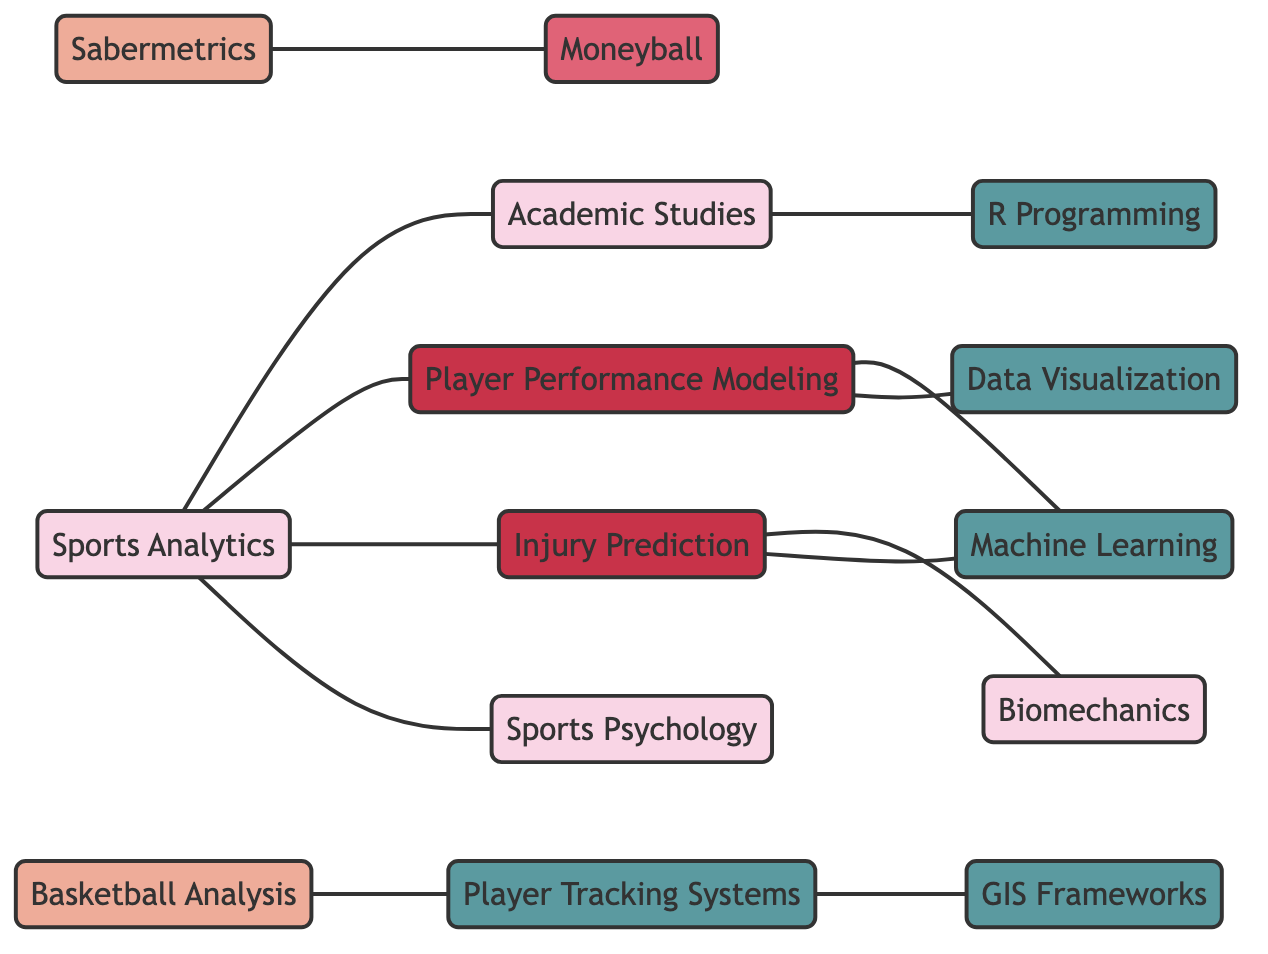What are the two main fields represented in the diagram? The two main fields represented as nodes are "Sports Analytics" and "Academic Studies." These nodes are central to understanding the interconnections illustrated in the network.
Answer: Sports Analytics, Academic Studies How many total nodes are present in the diagram? By counting each unique point of interest in the diagram, we find there are 13 distinct nodes representing different aspects of sports analytics and related fields.
Answer: 13 What methodology is connected to the case study "Moneyball"? The methodology directly linked to the "Moneyball" case study is "Sabermetrics." This connection suggests that "Moneyball" employs "Sabermetrics" as its analytical approach.
Answer: Sabermetrics Which technology is linked to "Player Performance Modeling"? "Machine Learning" is linked to "Player Performance Modeling" as a technology utilized to enhance understanding of player metrics and predictions.
Answer: Machine Learning How many research topics are present in the diagram? There are two distinct research topics present in the diagram: "Player Performance Modeling" and "Injury Prediction." Both focus on specific analytical challenges in sports.
Answer: 2 What field is associated with "Injury Prediction"? "Biomechanics" is associated with "Injury Prediction," suggesting a focus on the physical movements and mechanics that contribute to sports injuries.
Answer: Biomechanics Which technology is connected to "Player Tracking Systems"? The technology connected to "Player Tracking Systems" is "GIS Frameworks," indicating the use of geographical information systems in analyzing player movements.
Answer: GIS Frameworks What is the relationship between "Sports Analytics" and "Sports Psychology"? "Sports Analytics" is directly connected to "Sports Psychology," which implies an intersection between analytical methods and psychological factors in sports performance.
Answer: Directly connected How many edges are present in the diagram? To determine the total number of edges, we can count the connections between the nodes. There are 12 edges that represent the relationships between the different fields and methodologies.
Answer: 12 